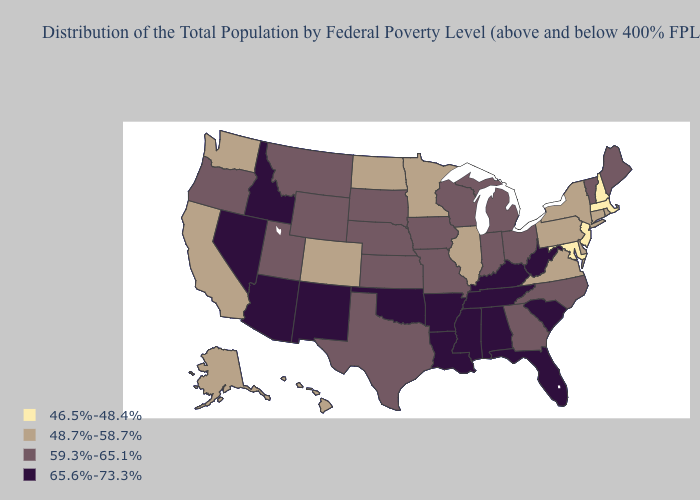What is the highest value in the USA?
Be succinct. 65.6%-73.3%. Name the states that have a value in the range 46.5%-48.4%?
Keep it brief. Maryland, Massachusetts, New Hampshire, New Jersey. Does Kansas have a lower value than California?
Answer briefly. No. Which states have the lowest value in the MidWest?
Answer briefly. Illinois, Minnesota, North Dakota. What is the lowest value in states that border Nevada?
Keep it brief. 48.7%-58.7%. Is the legend a continuous bar?
Be succinct. No. Name the states that have a value in the range 48.7%-58.7%?
Concise answer only. Alaska, California, Colorado, Connecticut, Delaware, Hawaii, Illinois, Minnesota, New York, North Dakota, Pennsylvania, Rhode Island, Virginia, Washington. What is the highest value in the USA?
Write a very short answer. 65.6%-73.3%. Name the states that have a value in the range 59.3%-65.1%?
Give a very brief answer. Georgia, Indiana, Iowa, Kansas, Maine, Michigan, Missouri, Montana, Nebraska, North Carolina, Ohio, Oregon, South Dakota, Texas, Utah, Vermont, Wisconsin, Wyoming. Does Massachusetts have the highest value in the Northeast?
Quick response, please. No. Which states hav the highest value in the South?
Write a very short answer. Alabama, Arkansas, Florida, Kentucky, Louisiana, Mississippi, Oklahoma, South Carolina, Tennessee, West Virginia. Does Massachusetts have a lower value than New Hampshire?
Quick response, please. No. Which states have the lowest value in the MidWest?
Give a very brief answer. Illinois, Minnesota, North Dakota. What is the value of West Virginia?
Write a very short answer. 65.6%-73.3%. What is the lowest value in states that border Kansas?
Answer briefly. 48.7%-58.7%. 